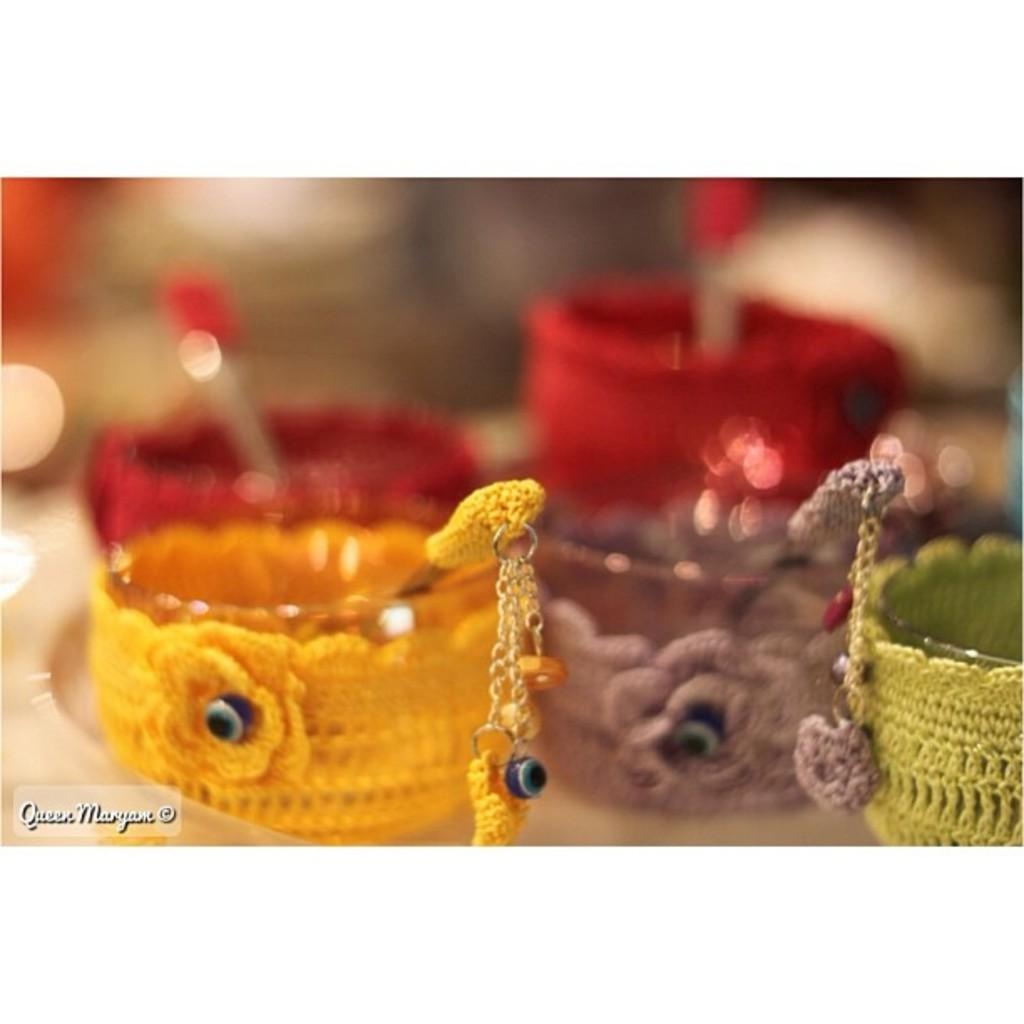What type of utensils are visible in the image? There are spoons in the image. What type of containers are visible in the image? There are cups in the image. Can you describe any additional features in the image? Yes, there is a watermark in the image. What type of curve can be seen in the middle of the image? There is no curve present in the middle of the image. What type of territory is depicted in the image? The image does not depict any territory; it features spoons, cups, and a watermark. 